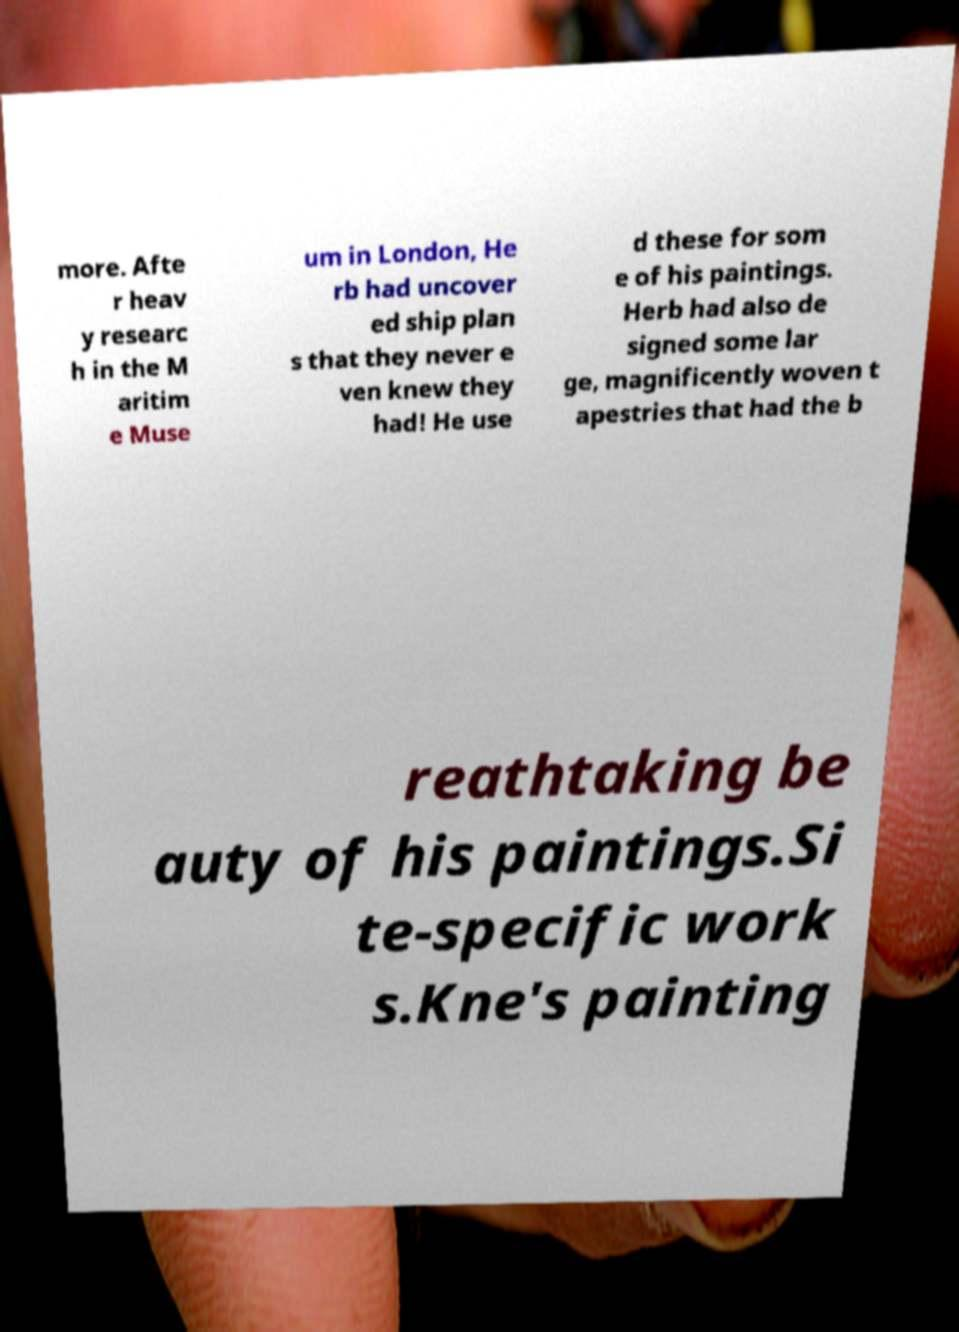For documentation purposes, I need the text within this image transcribed. Could you provide that? more. Afte r heav y researc h in the M aritim e Muse um in London, He rb had uncover ed ship plan s that they never e ven knew they had! He use d these for som e of his paintings. Herb had also de signed some lar ge, magnificently woven t apestries that had the b reathtaking be auty of his paintings.Si te-specific work s.Kne's painting 